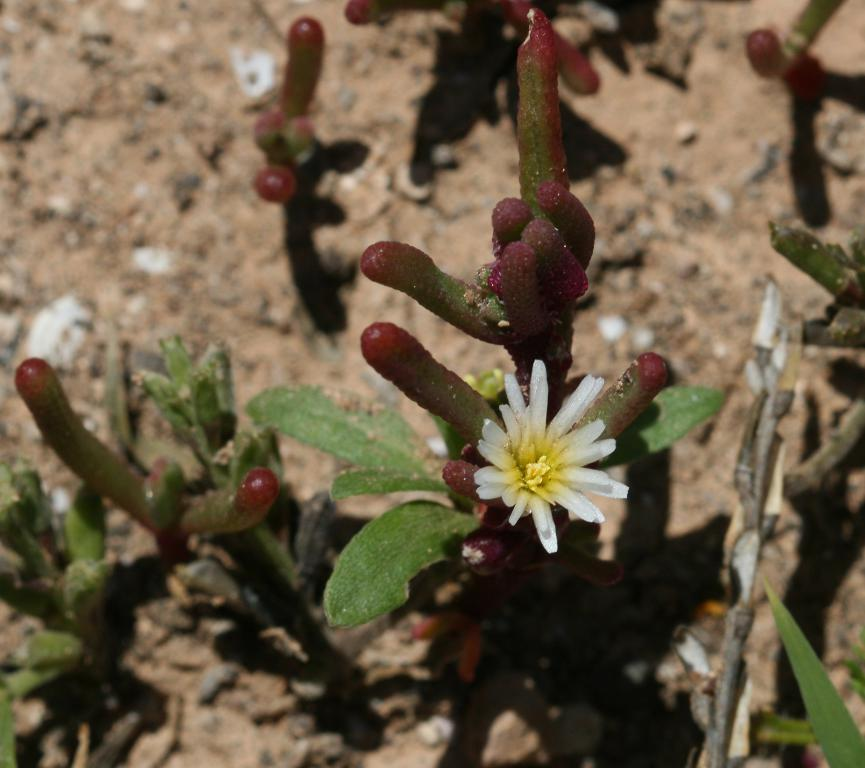What type of plants can be seen in the image? There are flowering plants in the image. What is the perspective of the image? The image appears to be taken on the ground. Can you describe the possible location of the image? The image may have been taken in a farm. When was the image likely taken? The image was likely taken during the day. What type of agreement is being discussed in the image? There is no discussion or agreement present in the image; it features flowering plants. What emotion is being expressed by the plants in the image? Plants do not express emotions like hate or any other emotion; they are inanimate objects. 